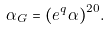<formula> <loc_0><loc_0><loc_500><loc_500>\alpha _ { G } = ( e ^ { q } \alpha ) ^ { 2 0 } .</formula> 